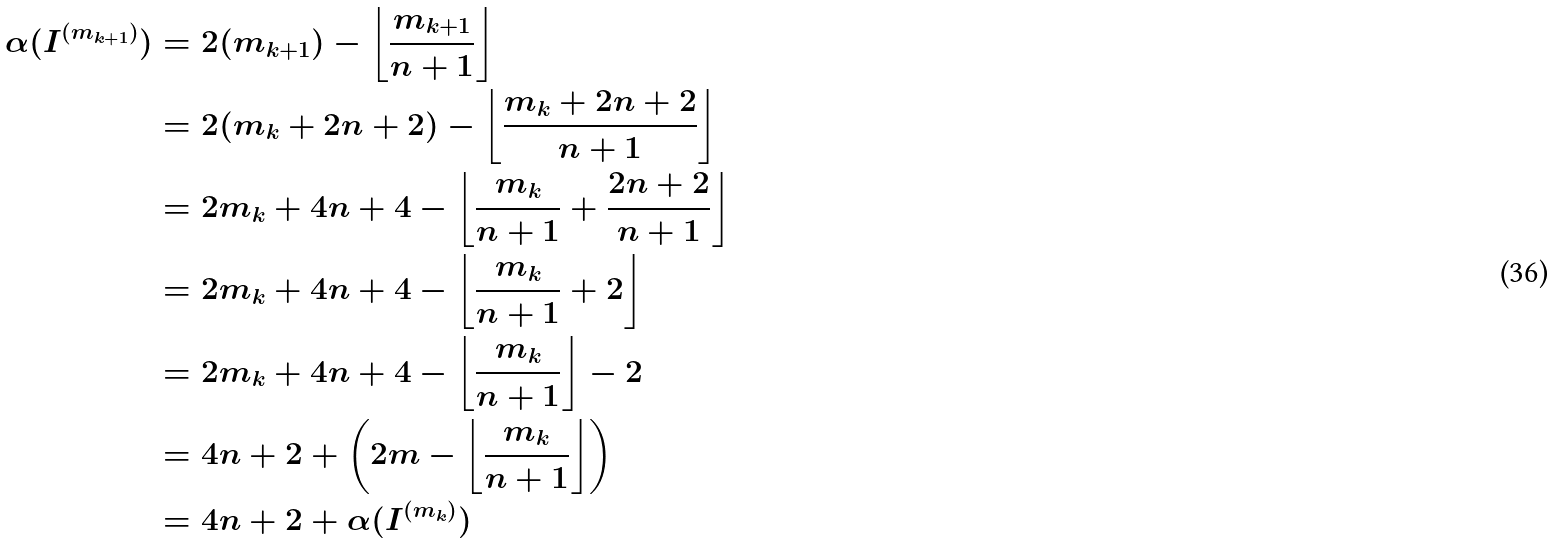<formula> <loc_0><loc_0><loc_500><loc_500>\alpha ( I ^ { ( m _ { k + 1 } ) } ) & = 2 ( m _ { k + 1 } ) - \left \lfloor \frac { m _ { k + 1 } } { n + 1 } \right \rfloor \\ & = 2 ( m _ { k } + 2 n + 2 ) - \left \lfloor \frac { m _ { k } + 2 n + 2 } { n + 1 } \right \rfloor \\ & = 2 m _ { k } + 4 n + 4 - \left \lfloor \frac { m _ { k } } { n + 1 } + \frac { 2 n + 2 } { n + 1 } \right \rfloor \\ & = 2 m _ { k } + 4 n + 4 - \left \lfloor \frac { m _ { k } } { n + 1 } + 2 \right \rfloor \\ & = 2 m _ { k } + 4 n + 4 - \left \lfloor \frac { m _ { k } } { n + 1 } \right \rfloor - 2 \\ & = 4 n + 2 + \left ( 2 m - \left \lfloor \frac { m _ { k } } { n + 1 } \right \rfloor \right ) \\ & = 4 n + 2 + \alpha ( I ^ { ( m _ { k } ) } )</formula> 